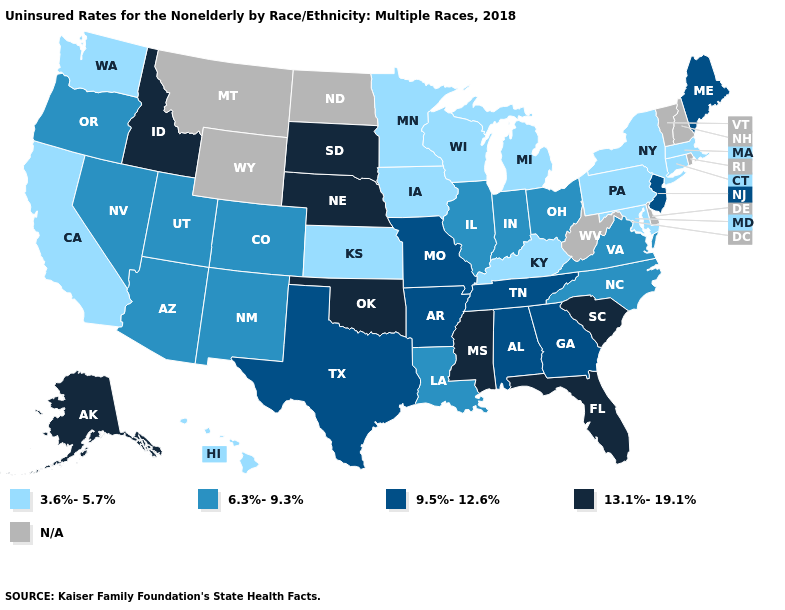Name the states that have a value in the range 3.6%-5.7%?
Quick response, please. California, Connecticut, Hawaii, Iowa, Kansas, Kentucky, Maryland, Massachusetts, Michigan, Minnesota, New York, Pennsylvania, Washington, Wisconsin. What is the lowest value in the MidWest?
Answer briefly. 3.6%-5.7%. How many symbols are there in the legend?
Short answer required. 5. Name the states that have a value in the range 13.1%-19.1%?
Keep it brief. Alaska, Florida, Idaho, Mississippi, Nebraska, Oklahoma, South Carolina, South Dakota. Name the states that have a value in the range 13.1%-19.1%?
Quick response, please. Alaska, Florida, Idaho, Mississippi, Nebraska, Oklahoma, South Carolina, South Dakota. How many symbols are there in the legend?
Short answer required. 5. Does Mississippi have the highest value in the USA?
Quick response, please. Yes. Is the legend a continuous bar?
Quick response, please. No. Name the states that have a value in the range 13.1%-19.1%?
Write a very short answer. Alaska, Florida, Idaho, Mississippi, Nebraska, Oklahoma, South Carolina, South Dakota. Name the states that have a value in the range 6.3%-9.3%?
Give a very brief answer. Arizona, Colorado, Illinois, Indiana, Louisiana, Nevada, New Mexico, North Carolina, Ohio, Oregon, Utah, Virginia. Name the states that have a value in the range 13.1%-19.1%?
Short answer required. Alaska, Florida, Idaho, Mississippi, Nebraska, Oklahoma, South Carolina, South Dakota. What is the highest value in the USA?
Quick response, please. 13.1%-19.1%. What is the value of Nevada?
Quick response, please. 6.3%-9.3%. 